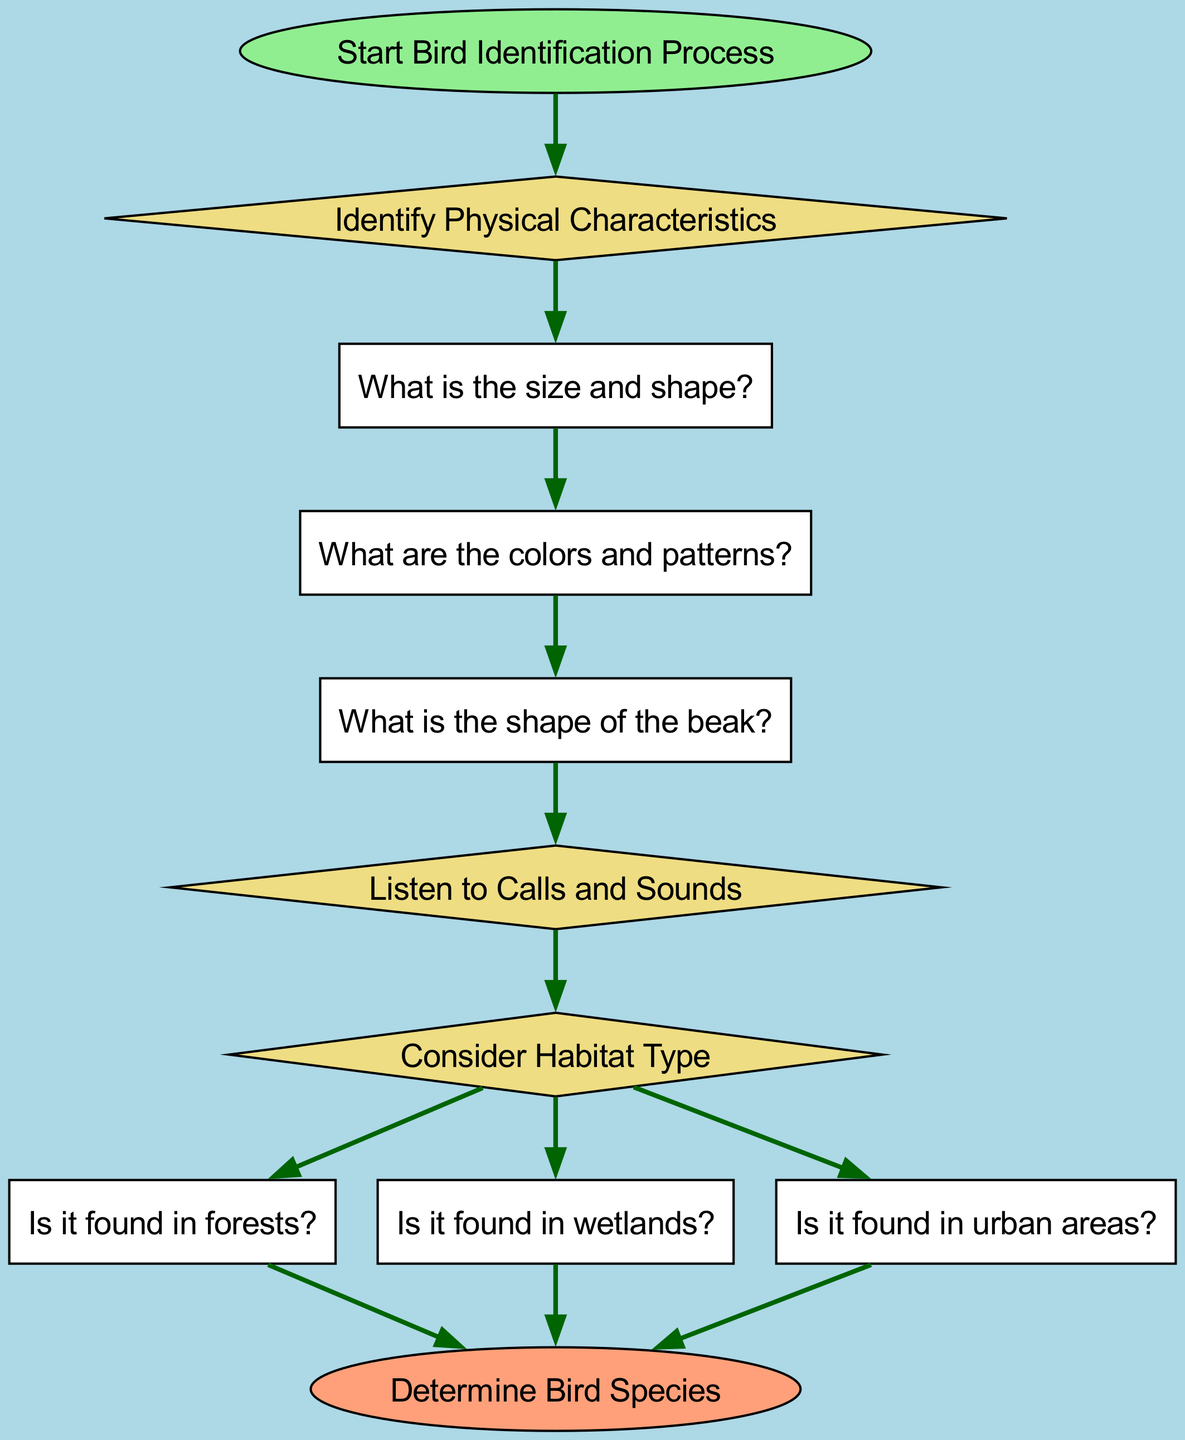What is the first step in the bird identification process? The first step is represented by the "Start Bird Identification Process" node, which initiates the flowchart and signifies where the process begins.
Answer: Start Bird Identification Process How many decision nodes are present in the diagram? By reviewing the diagram, there are a total of four decision nodes: "Identify Physical Characteristics," "Listen to Calls and Sounds," and "Consider Habitat Type." Each is a decision point that requires a yes/no response.
Answer: 4 What characteristic is evaluated after identifying size and shape? Following the identification of size and shape, the next characteristic to evaluate is "What are the colors and patterns?" which is the subsequent node in the flowchart.
Answer: What are the colors and patterns? If a bird is found in urban areas, what is the next action? If the bird is identified as being found in urban areas, it leads directly to the "Determine Bird Species" node, which concludes the identification process.
Answer: Determine Bird Species Which elements are connected by the edge that follows "Listen to Calls and Sounds"? The edge following "Listen to Calls and Sounds" connects to the "Consider Habitat Type" decision node, indicating the progression of the identification workflow after assessing bird calls and sounds.
Answer: Consider Habitat Type What paths can lead to determining a bird's species? The paths leading to "Determine Bird Species" can come from three different habitat types: forest, wetland, and urban area, showing the diversity of environments where birds can be identified.
Answer: Forest, Wetland, Urban Area What shape is used for the "Identify Physical Characteristics" node? The "Identify Physical Characteristics" node is represented as a diamond shape, which indicates a decision point in the flowchart, requiring the observer to assess certain characteristics.
Answer: Diamond What is the last question to ask in the process? The final question before reaching the end of the flowchart is related to the habitat type, asking if the bird is found in forests, wetlands, or urban areas, leading towards determining the species.
Answer: Is it found in forests? 